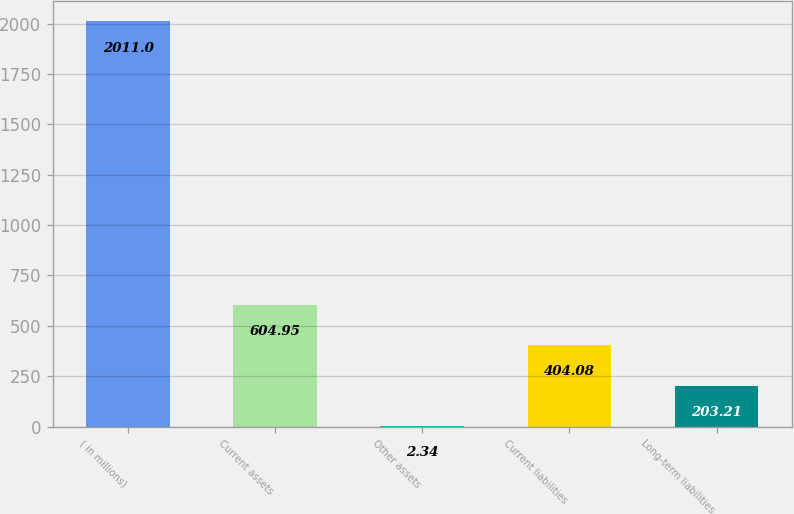Convert chart. <chart><loc_0><loc_0><loc_500><loc_500><bar_chart><fcel>( in millions)<fcel>Current assets<fcel>Other assets<fcel>Current liabilities<fcel>Long-term liabilities<nl><fcel>2011<fcel>604.95<fcel>2.34<fcel>404.08<fcel>203.21<nl></chart> 